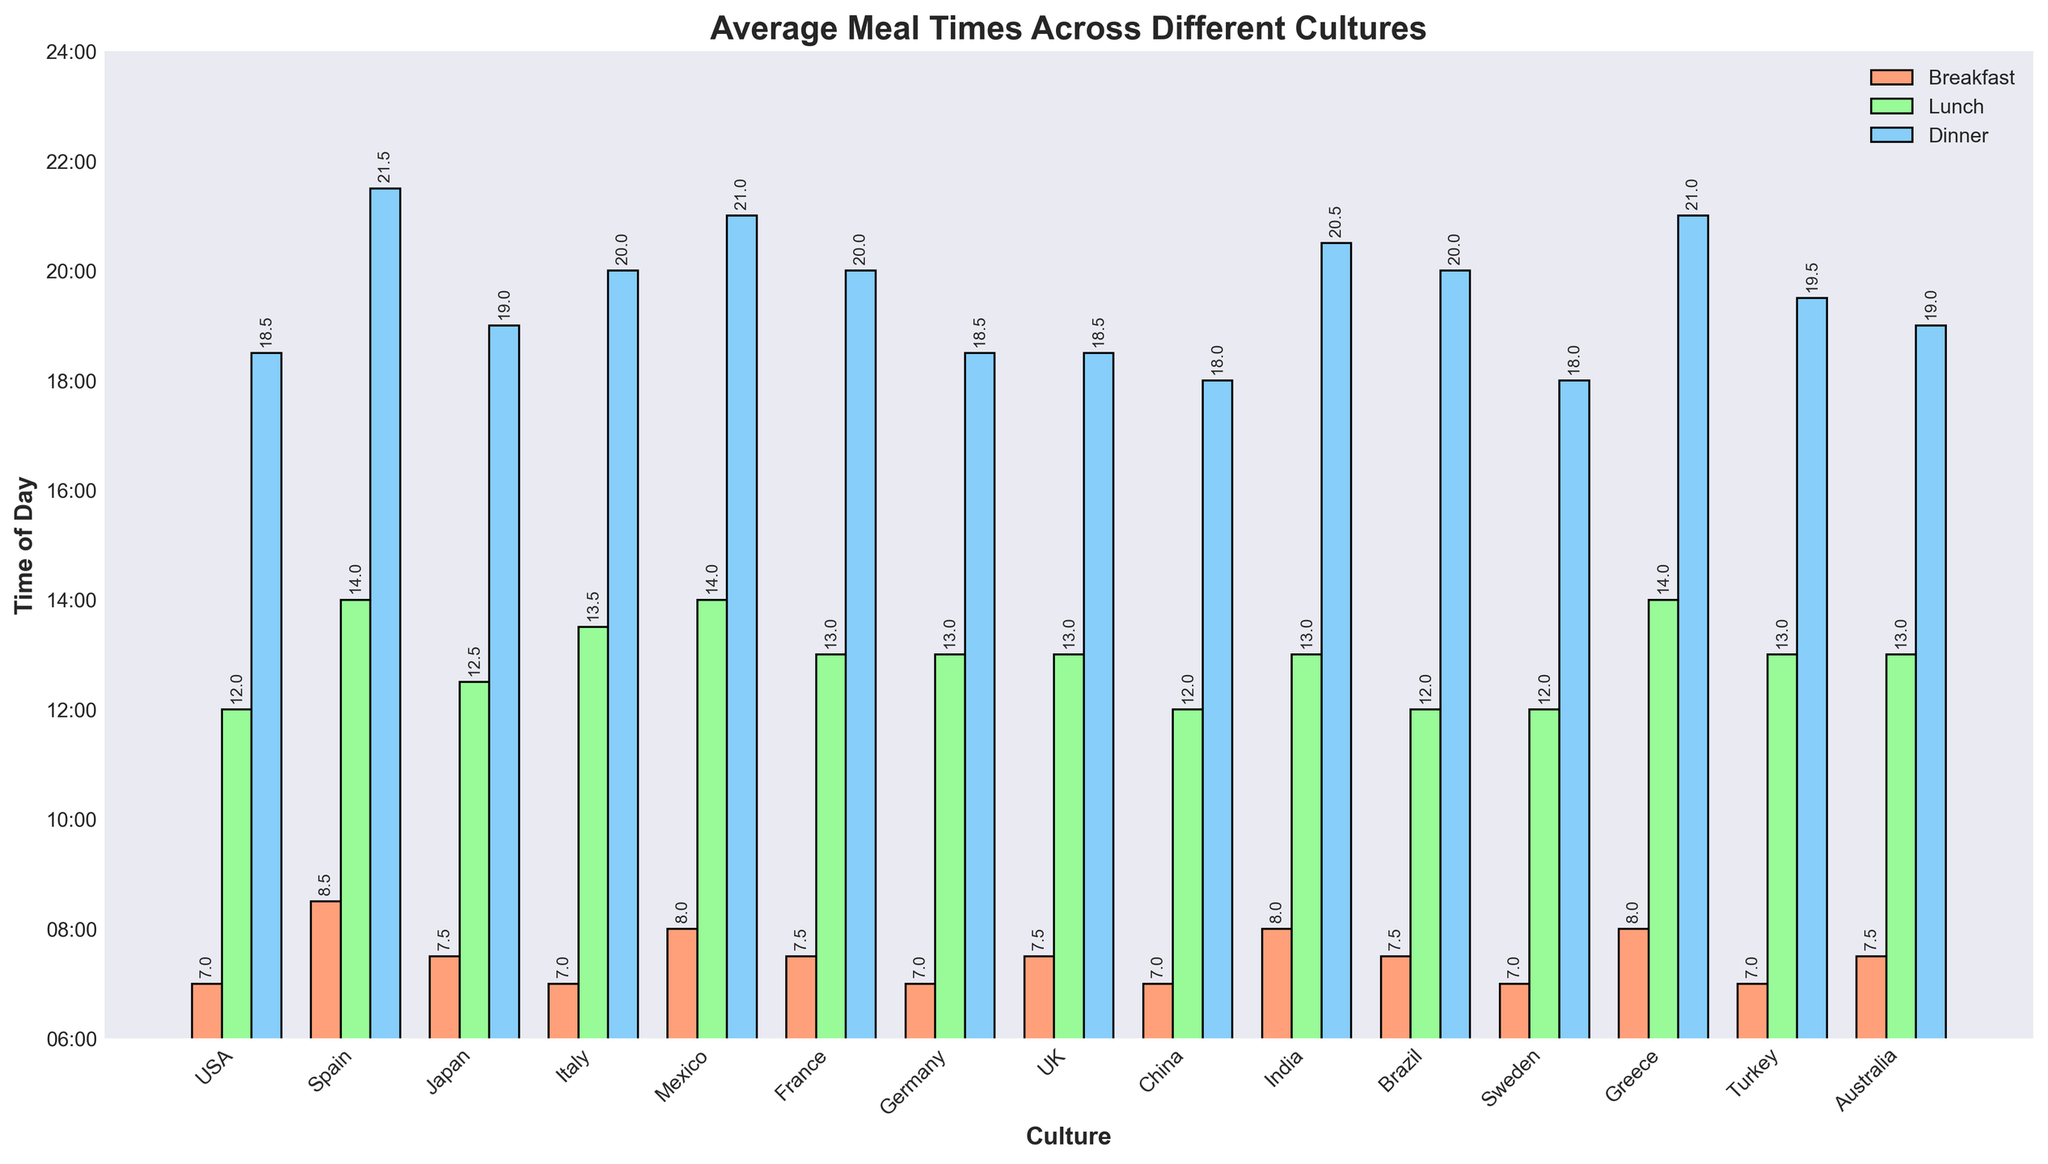Which culture has the latest lunch time? To determine the latest lunch time, look at the green bars which represent lunch times and identify the bar that is highest on the x-axis. Spain and Greece both have the latest lunch times at 14:00.
Answer: Spain and Greece What is the average breakfast time across all cultures? Convert each breakfast time to its numerical hour equivalent: USA 7, Spain 8.5, Japan 7.5, Italy 7, Mexico 8, France 7.5, Germany 7, UK 7.5, China 7, India 8, Brazil 7.5, Sweden 7, Greece 8, Turkey 7, Australia 7.5. Sum these and divide by 15: (7+8.5+7.5+7+8+7.5+7+7.5+7+8+7.5+7+8+7+7.5)/15 = 7.4.
Answer: 7:24 Which two cultures have the greatest difference in dinner times? Identify the highest and lowest positions of the blue bars on the x-axis. Spain's dinner (21.5) minus Sweden's dinner (18) equals 3.5 hours.
Answer: Spain and Sweden How many cultures have their dinner time at or after 20:00? Count how many blue bars are at the 20-hour mark or higher: Spain, Italy, Mexico, France, India, Brazil, Greece. Seven cultures meet this criterion.
Answer: Seven What time do most cultures eat lunch? Notice the clustering of green bars around certain times. Most green bars (8 cultures) are at 13:00.
Answer: 13:00 Which culture has the closest meal times between breakfast and dinner? Calculate the difference between breakfast and dinner times for each culture, then find the minimum difference: China (18-7 = 11 hours).
Answer: China Is there a culture that has a consistent meal schedule, with meals spaced evenly throughout the day? Evaluate the hour differences between breakfast, lunch, and dinner for each culture and find the one with the most uniform time intervals. China's times (7:00, 12:00, 18:00) are evenly spaced at 5-hour intervals.
Answer: China What visual cue indicates when lunch is served in Germany compared to France? Look at the green bars for Germany and France; both are at 13:00.
Answer: Same time 